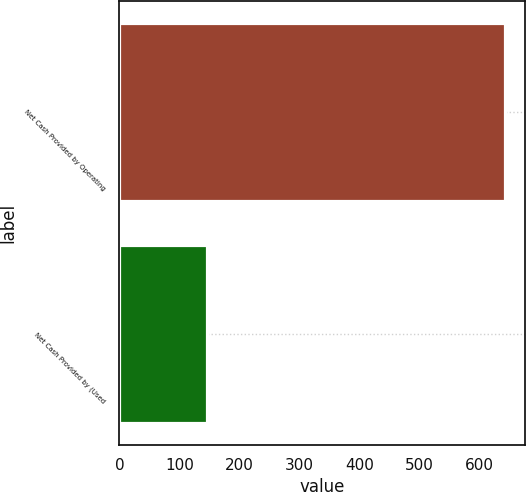Convert chart. <chart><loc_0><loc_0><loc_500><loc_500><bar_chart><fcel>Net Cash Provided by Operating<fcel>Net Cash Provided by (Used<nl><fcel>642.8<fcel>145.7<nl></chart> 